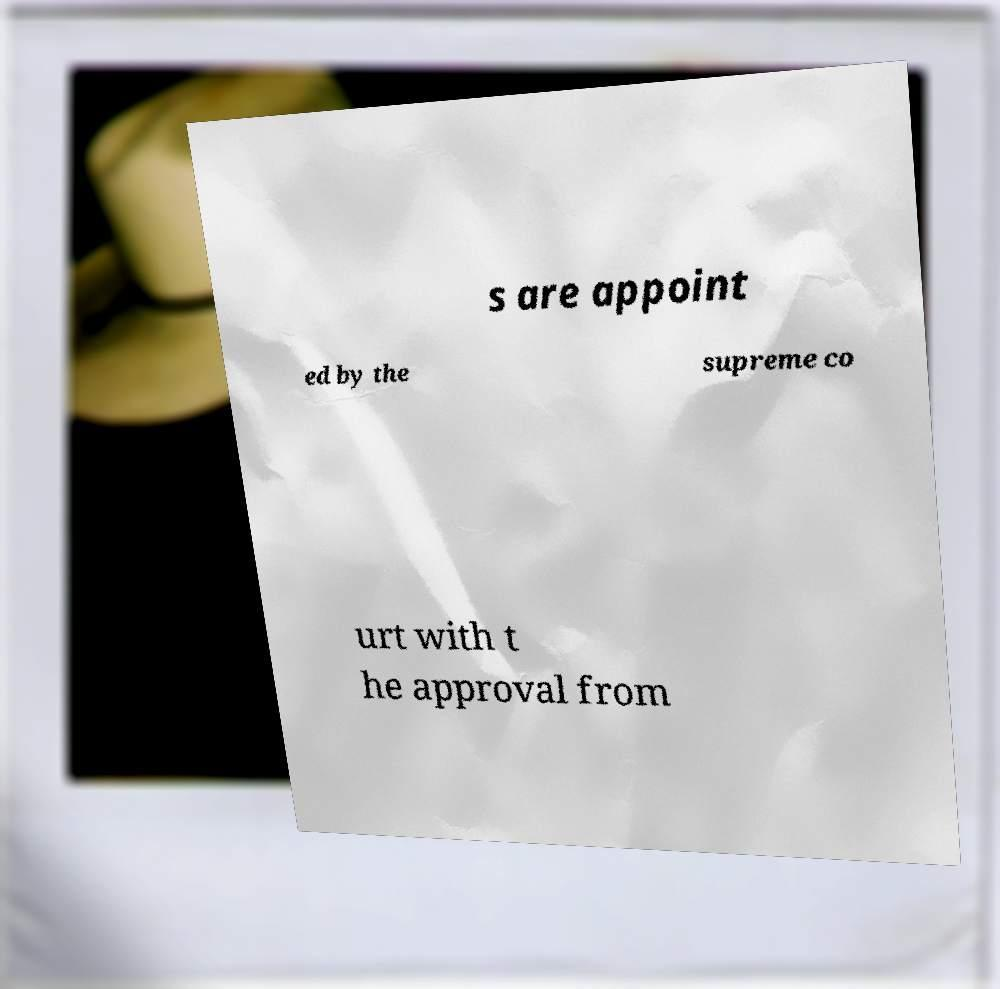I need the written content from this picture converted into text. Can you do that? s are appoint ed by the supreme co urt with t he approval from 